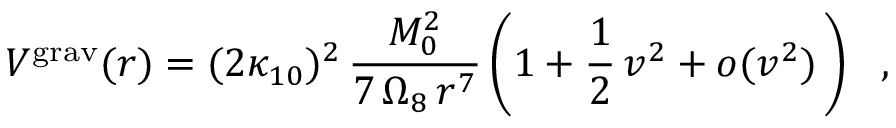<formula> <loc_0><loc_0><loc_500><loc_500>V ^ { g r a v } ( r ) = ( 2 \kappa _ { 1 0 } ) ^ { 2 } \, { \frac { M _ { 0 } ^ { 2 } } { 7 \, \Omega _ { 8 } \, r ^ { 7 } } } \left ( 1 + \frac { 1 } { 2 } \, v ^ { 2 } + o ( v ^ { 2 } ) \, \right ) ,</formula> 